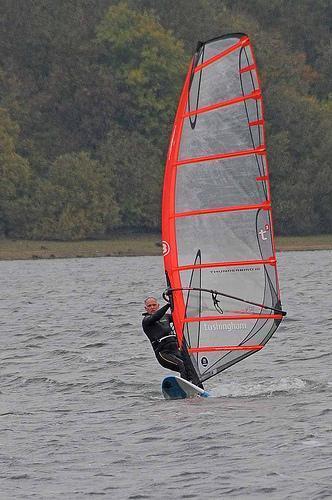How many people in the picture?
Give a very brief answer. 1. 